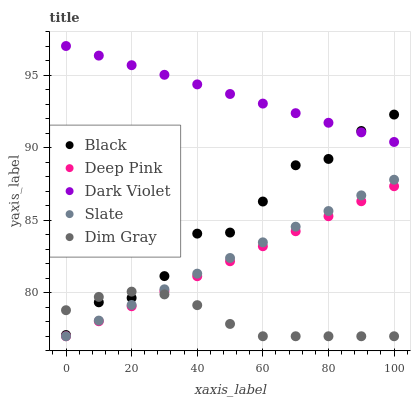Does Dim Gray have the minimum area under the curve?
Answer yes or no. Yes. Does Dark Violet have the maximum area under the curve?
Answer yes or no. Yes. Does Slate have the minimum area under the curve?
Answer yes or no. No. Does Slate have the maximum area under the curve?
Answer yes or no. No. Is Dark Violet the smoothest?
Answer yes or no. Yes. Is Black the roughest?
Answer yes or no. Yes. Is Slate the smoothest?
Answer yes or no. No. Is Slate the roughest?
Answer yes or no. No. Does Dim Gray have the lowest value?
Answer yes or no. Yes. Does Black have the lowest value?
Answer yes or no. No. Does Dark Violet have the highest value?
Answer yes or no. Yes. Does Slate have the highest value?
Answer yes or no. No. Is Deep Pink less than Dark Violet?
Answer yes or no. Yes. Is Dark Violet greater than Slate?
Answer yes or no. Yes. Does Dim Gray intersect Slate?
Answer yes or no. Yes. Is Dim Gray less than Slate?
Answer yes or no. No. Is Dim Gray greater than Slate?
Answer yes or no. No. Does Deep Pink intersect Dark Violet?
Answer yes or no. No. 